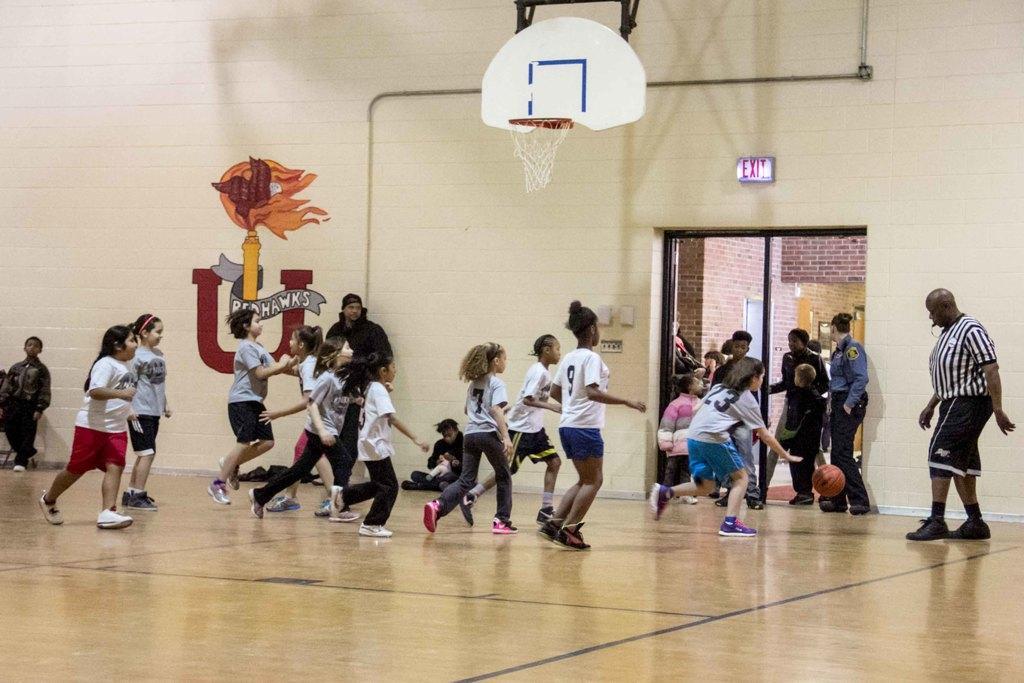How would you summarize this image in a sentence or two? It is a basketball court,the kids are playing the basketball and in front of the kids a man is standing and blowing a whistle and in the right side of the room there is an exit board security guard is standing in front of the door. 